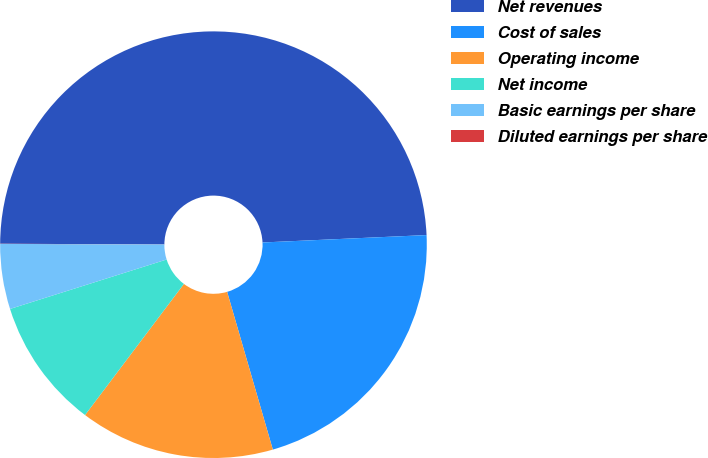Convert chart to OTSL. <chart><loc_0><loc_0><loc_500><loc_500><pie_chart><fcel>Net revenues<fcel>Cost of sales<fcel>Operating income<fcel>Net income<fcel>Basic earnings per share<fcel>Diluted earnings per share<nl><fcel>49.21%<fcel>21.23%<fcel>14.77%<fcel>9.85%<fcel>4.93%<fcel>0.01%<nl></chart> 